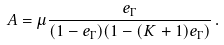Convert formula to latex. <formula><loc_0><loc_0><loc_500><loc_500>A = \mu \frac { e _ { \Gamma } } { ( 1 - e _ { \Gamma } ) ( 1 - ( K + 1 ) e _ { \Gamma } ) } \, .</formula> 